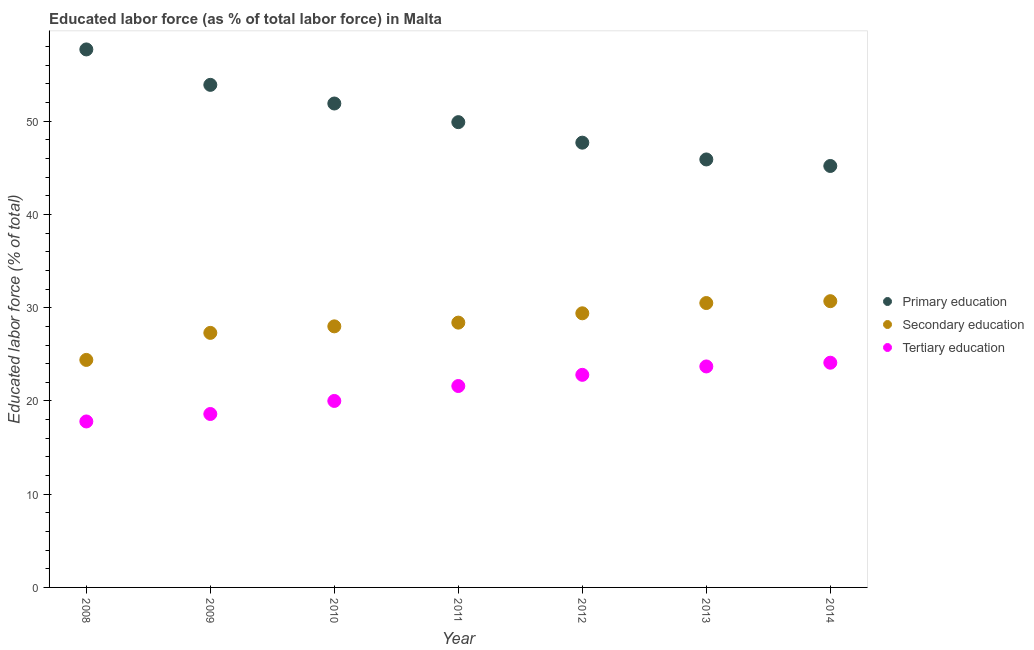Is the number of dotlines equal to the number of legend labels?
Give a very brief answer. Yes. What is the percentage of labor force who received tertiary education in 2013?
Ensure brevity in your answer.  23.7. Across all years, what is the maximum percentage of labor force who received tertiary education?
Provide a short and direct response. 24.1. Across all years, what is the minimum percentage of labor force who received tertiary education?
Keep it short and to the point. 17.8. In which year was the percentage of labor force who received primary education minimum?
Your answer should be very brief. 2014. What is the total percentage of labor force who received secondary education in the graph?
Ensure brevity in your answer.  198.7. What is the difference between the percentage of labor force who received secondary education in 2008 and that in 2013?
Provide a succinct answer. -6.1. What is the difference between the percentage of labor force who received secondary education in 2014 and the percentage of labor force who received primary education in 2013?
Offer a terse response. -15.2. What is the average percentage of labor force who received primary education per year?
Your answer should be compact. 50.31. In the year 2012, what is the difference between the percentage of labor force who received primary education and percentage of labor force who received secondary education?
Your response must be concise. 18.3. What is the ratio of the percentage of labor force who received secondary education in 2010 to that in 2011?
Provide a short and direct response. 0.99. What is the difference between the highest and the second highest percentage of labor force who received secondary education?
Keep it short and to the point. 0.2. What is the difference between the highest and the lowest percentage of labor force who received primary education?
Make the answer very short. 12.5. In how many years, is the percentage of labor force who received secondary education greater than the average percentage of labor force who received secondary education taken over all years?
Offer a very short reply. 4. Is it the case that in every year, the sum of the percentage of labor force who received primary education and percentage of labor force who received secondary education is greater than the percentage of labor force who received tertiary education?
Ensure brevity in your answer.  Yes. Does the percentage of labor force who received primary education monotonically increase over the years?
Offer a very short reply. No. Is the percentage of labor force who received secondary education strictly less than the percentage of labor force who received tertiary education over the years?
Offer a terse response. No. How many dotlines are there?
Offer a terse response. 3. How many years are there in the graph?
Ensure brevity in your answer.  7. What is the difference between two consecutive major ticks on the Y-axis?
Make the answer very short. 10. Does the graph contain any zero values?
Keep it short and to the point. No. How are the legend labels stacked?
Offer a very short reply. Vertical. What is the title of the graph?
Ensure brevity in your answer.  Educated labor force (as % of total labor force) in Malta. Does "Ages 65 and above" appear as one of the legend labels in the graph?
Your answer should be compact. No. What is the label or title of the Y-axis?
Your answer should be compact. Educated labor force (% of total). What is the Educated labor force (% of total) in Primary education in 2008?
Offer a terse response. 57.7. What is the Educated labor force (% of total) of Secondary education in 2008?
Your response must be concise. 24.4. What is the Educated labor force (% of total) in Tertiary education in 2008?
Ensure brevity in your answer.  17.8. What is the Educated labor force (% of total) of Primary education in 2009?
Offer a terse response. 53.9. What is the Educated labor force (% of total) of Secondary education in 2009?
Your response must be concise. 27.3. What is the Educated labor force (% of total) of Tertiary education in 2009?
Your response must be concise. 18.6. What is the Educated labor force (% of total) in Primary education in 2010?
Make the answer very short. 51.9. What is the Educated labor force (% of total) of Tertiary education in 2010?
Offer a terse response. 20. What is the Educated labor force (% of total) in Primary education in 2011?
Offer a very short reply. 49.9. What is the Educated labor force (% of total) of Secondary education in 2011?
Your answer should be compact. 28.4. What is the Educated labor force (% of total) in Tertiary education in 2011?
Keep it short and to the point. 21.6. What is the Educated labor force (% of total) in Primary education in 2012?
Your response must be concise. 47.7. What is the Educated labor force (% of total) of Secondary education in 2012?
Offer a terse response. 29.4. What is the Educated labor force (% of total) of Tertiary education in 2012?
Provide a succinct answer. 22.8. What is the Educated labor force (% of total) in Primary education in 2013?
Make the answer very short. 45.9. What is the Educated labor force (% of total) of Secondary education in 2013?
Provide a short and direct response. 30.5. What is the Educated labor force (% of total) of Tertiary education in 2013?
Your answer should be compact. 23.7. What is the Educated labor force (% of total) of Primary education in 2014?
Your response must be concise. 45.2. What is the Educated labor force (% of total) of Secondary education in 2014?
Provide a succinct answer. 30.7. What is the Educated labor force (% of total) in Tertiary education in 2014?
Your answer should be compact. 24.1. Across all years, what is the maximum Educated labor force (% of total) of Primary education?
Provide a succinct answer. 57.7. Across all years, what is the maximum Educated labor force (% of total) of Secondary education?
Provide a short and direct response. 30.7. Across all years, what is the maximum Educated labor force (% of total) of Tertiary education?
Provide a short and direct response. 24.1. Across all years, what is the minimum Educated labor force (% of total) in Primary education?
Provide a succinct answer. 45.2. Across all years, what is the minimum Educated labor force (% of total) in Secondary education?
Offer a very short reply. 24.4. Across all years, what is the minimum Educated labor force (% of total) in Tertiary education?
Keep it short and to the point. 17.8. What is the total Educated labor force (% of total) of Primary education in the graph?
Ensure brevity in your answer.  352.2. What is the total Educated labor force (% of total) in Secondary education in the graph?
Provide a short and direct response. 198.7. What is the total Educated labor force (% of total) of Tertiary education in the graph?
Offer a very short reply. 148.6. What is the difference between the Educated labor force (% of total) in Primary education in 2008 and that in 2009?
Give a very brief answer. 3.8. What is the difference between the Educated labor force (% of total) in Secondary education in 2008 and that in 2009?
Ensure brevity in your answer.  -2.9. What is the difference between the Educated labor force (% of total) of Secondary education in 2008 and that in 2010?
Offer a very short reply. -3.6. What is the difference between the Educated labor force (% of total) of Tertiary education in 2008 and that in 2010?
Provide a short and direct response. -2.2. What is the difference between the Educated labor force (% of total) in Tertiary education in 2008 and that in 2011?
Your response must be concise. -3.8. What is the difference between the Educated labor force (% of total) of Primary education in 2008 and that in 2012?
Offer a very short reply. 10. What is the difference between the Educated labor force (% of total) in Secondary education in 2008 and that in 2012?
Your answer should be very brief. -5. What is the difference between the Educated labor force (% of total) of Primary education in 2008 and that in 2013?
Give a very brief answer. 11.8. What is the difference between the Educated labor force (% of total) of Tertiary education in 2008 and that in 2013?
Offer a terse response. -5.9. What is the difference between the Educated labor force (% of total) of Secondary education in 2009 and that in 2010?
Your answer should be very brief. -0.7. What is the difference between the Educated labor force (% of total) in Tertiary education in 2009 and that in 2010?
Keep it short and to the point. -1.4. What is the difference between the Educated labor force (% of total) in Secondary education in 2009 and that in 2012?
Make the answer very short. -2.1. What is the difference between the Educated labor force (% of total) of Primary education in 2009 and that in 2013?
Your response must be concise. 8. What is the difference between the Educated labor force (% of total) in Secondary education in 2009 and that in 2013?
Your answer should be very brief. -3.2. What is the difference between the Educated labor force (% of total) in Tertiary education in 2009 and that in 2013?
Your answer should be compact. -5.1. What is the difference between the Educated labor force (% of total) of Secondary education in 2009 and that in 2014?
Make the answer very short. -3.4. What is the difference between the Educated labor force (% of total) in Tertiary education in 2010 and that in 2011?
Your answer should be very brief. -1.6. What is the difference between the Educated labor force (% of total) in Primary education in 2010 and that in 2012?
Your response must be concise. 4.2. What is the difference between the Educated labor force (% of total) in Secondary education in 2010 and that in 2012?
Offer a very short reply. -1.4. What is the difference between the Educated labor force (% of total) of Primary education in 2010 and that in 2013?
Keep it short and to the point. 6. What is the difference between the Educated labor force (% of total) of Tertiary education in 2010 and that in 2013?
Your answer should be very brief. -3.7. What is the difference between the Educated labor force (% of total) of Primary education in 2010 and that in 2014?
Offer a very short reply. 6.7. What is the difference between the Educated labor force (% of total) in Secondary education in 2011 and that in 2012?
Make the answer very short. -1. What is the difference between the Educated labor force (% of total) in Tertiary education in 2011 and that in 2012?
Your response must be concise. -1.2. What is the difference between the Educated labor force (% of total) in Secondary education in 2012 and that in 2013?
Provide a succinct answer. -1.1. What is the difference between the Educated labor force (% of total) of Tertiary education in 2012 and that in 2013?
Make the answer very short. -0.9. What is the difference between the Educated labor force (% of total) of Primary education in 2012 and that in 2014?
Offer a terse response. 2.5. What is the difference between the Educated labor force (% of total) of Secondary education in 2012 and that in 2014?
Make the answer very short. -1.3. What is the difference between the Educated labor force (% of total) in Primary education in 2013 and that in 2014?
Offer a very short reply. 0.7. What is the difference between the Educated labor force (% of total) of Secondary education in 2013 and that in 2014?
Provide a succinct answer. -0.2. What is the difference between the Educated labor force (% of total) in Tertiary education in 2013 and that in 2014?
Offer a very short reply. -0.4. What is the difference between the Educated labor force (% of total) in Primary education in 2008 and the Educated labor force (% of total) in Secondary education in 2009?
Your response must be concise. 30.4. What is the difference between the Educated labor force (% of total) in Primary education in 2008 and the Educated labor force (% of total) in Tertiary education in 2009?
Ensure brevity in your answer.  39.1. What is the difference between the Educated labor force (% of total) in Secondary education in 2008 and the Educated labor force (% of total) in Tertiary education in 2009?
Your response must be concise. 5.8. What is the difference between the Educated labor force (% of total) in Primary education in 2008 and the Educated labor force (% of total) in Secondary education in 2010?
Keep it short and to the point. 29.7. What is the difference between the Educated labor force (% of total) of Primary education in 2008 and the Educated labor force (% of total) of Tertiary education in 2010?
Provide a succinct answer. 37.7. What is the difference between the Educated labor force (% of total) of Secondary education in 2008 and the Educated labor force (% of total) of Tertiary education in 2010?
Keep it short and to the point. 4.4. What is the difference between the Educated labor force (% of total) of Primary education in 2008 and the Educated labor force (% of total) of Secondary education in 2011?
Ensure brevity in your answer.  29.3. What is the difference between the Educated labor force (% of total) of Primary education in 2008 and the Educated labor force (% of total) of Tertiary education in 2011?
Ensure brevity in your answer.  36.1. What is the difference between the Educated labor force (% of total) in Secondary education in 2008 and the Educated labor force (% of total) in Tertiary education in 2011?
Give a very brief answer. 2.8. What is the difference between the Educated labor force (% of total) of Primary education in 2008 and the Educated labor force (% of total) of Secondary education in 2012?
Make the answer very short. 28.3. What is the difference between the Educated labor force (% of total) of Primary education in 2008 and the Educated labor force (% of total) of Tertiary education in 2012?
Keep it short and to the point. 34.9. What is the difference between the Educated labor force (% of total) of Secondary education in 2008 and the Educated labor force (% of total) of Tertiary education in 2012?
Give a very brief answer. 1.6. What is the difference between the Educated labor force (% of total) of Primary education in 2008 and the Educated labor force (% of total) of Secondary education in 2013?
Keep it short and to the point. 27.2. What is the difference between the Educated labor force (% of total) of Primary education in 2008 and the Educated labor force (% of total) of Tertiary education in 2013?
Offer a very short reply. 34. What is the difference between the Educated labor force (% of total) in Secondary education in 2008 and the Educated labor force (% of total) in Tertiary education in 2013?
Ensure brevity in your answer.  0.7. What is the difference between the Educated labor force (% of total) in Primary education in 2008 and the Educated labor force (% of total) in Secondary education in 2014?
Ensure brevity in your answer.  27. What is the difference between the Educated labor force (% of total) of Primary education in 2008 and the Educated labor force (% of total) of Tertiary education in 2014?
Your answer should be very brief. 33.6. What is the difference between the Educated labor force (% of total) of Secondary education in 2008 and the Educated labor force (% of total) of Tertiary education in 2014?
Give a very brief answer. 0.3. What is the difference between the Educated labor force (% of total) in Primary education in 2009 and the Educated labor force (% of total) in Secondary education in 2010?
Give a very brief answer. 25.9. What is the difference between the Educated labor force (% of total) of Primary education in 2009 and the Educated labor force (% of total) of Tertiary education in 2010?
Provide a short and direct response. 33.9. What is the difference between the Educated labor force (% of total) of Secondary education in 2009 and the Educated labor force (% of total) of Tertiary education in 2010?
Make the answer very short. 7.3. What is the difference between the Educated labor force (% of total) in Primary education in 2009 and the Educated labor force (% of total) in Secondary education in 2011?
Make the answer very short. 25.5. What is the difference between the Educated labor force (% of total) of Primary education in 2009 and the Educated labor force (% of total) of Tertiary education in 2011?
Make the answer very short. 32.3. What is the difference between the Educated labor force (% of total) in Primary education in 2009 and the Educated labor force (% of total) in Secondary education in 2012?
Make the answer very short. 24.5. What is the difference between the Educated labor force (% of total) in Primary education in 2009 and the Educated labor force (% of total) in Tertiary education in 2012?
Give a very brief answer. 31.1. What is the difference between the Educated labor force (% of total) of Secondary education in 2009 and the Educated labor force (% of total) of Tertiary education in 2012?
Your answer should be very brief. 4.5. What is the difference between the Educated labor force (% of total) in Primary education in 2009 and the Educated labor force (% of total) in Secondary education in 2013?
Offer a very short reply. 23.4. What is the difference between the Educated labor force (% of total) of Primary education in 2009 and the Educated labor force (% of total) of Tertiary education in 2013?
Offer a very short reply. 30.2. What is the difference between the Educated labor force (% of total) in Secondary education in 2009 and the Educated labor force (% of total) in Tertiary education in 2013?
Keep it short and to the point. 3.6. What is the difference between the Educated labor force (% of total) of Primary education in 2009 and the Educated labor force (% of total) of Secondary education in 2014?
Offer a terse response. 23.2. What is the difference between the Educated labor force (% of total) of Primary education in 2009 and the Educated labor force (% of total) of Tertiary education in 2014?
Ensure brevity in your answer.  29.8. What is the difference between the Educated labor force (% of total) of Secondary education in 2009 and the Educated labor force (% of total) of Tertiary education in 2014?
Your answer should be compact. 3.2. What is the difference between the Educated labor force (% of total) of Primary education in 2010 and the Educated labor force (% of total) of Secondary education in 2011?
Make the answer very short. 23.5. What is the difference between the Educated labor force (% of total) of Primary education in 2010 and the Educated labor force (% of total) of Tertiary education in 2011?
Your response must be concise. 30.3. What is the difference between the Educated labor force (% of total) of Primary education in 2010 and the Educated labor force (% of total) of Secondary education in 2012?
Your answer should be very brief. 22.5. What is the difference between the Educated labor force (% of total) in Primary education in 2010 and the Educated labor force (% of total) in Tertiary education in 2012?
Ensure brevity in your answer.  29.1. What is the difference between the Educated labor force (% of total) in Secondary education in 2010 and the Educated labor force (% of total) in Tertiary education in 2012?
Ensure brevity in your answer.  5.2. What is the difference between the Educated labor force (% of total) of Primary education in 2010 and the Educated labor force (% of total) of Secondary education in 2013?
Provide a succinct answer. 21.4. What is the difference between the Educated labor force (% of total) of Primary education in 2010 and the Educated labor force (% of total) of Tertiary education in 2013?
Your answer should be compact. 28.2. What is the difference between the Educated labor force (% of total) of Secondary education in 2010 and the Educated labor force (% of total) of Tertiary education in 2013?
Offer a very short reply. 4.3. What is the difference between the Educated labor force (% of total) in Primary education in 2010 and the Educated labor force (% of total) in Secondary education in 2014?
Your response must be concise. 21.2. What is the difference between the Educated labor force (% of total) in Primary education in 2010 and the Educated labor force (% of total) in Tertiary education in 2014?
Your response must be concise. 27.8. What is the difference between the Educated labor force (% of total) in Secondary education in 2010 and the Educated labor force (% of total) in Tertiary education in 2014?
Make the answer very short. 3.9. What is the difference between the Educated labor force (% of total) in Primary education in 2011 and the Educated labor force (% of total) in Secondary education in 2012?
Keep it short and to the point. 20.5. What is the difference between the Educated labor force (% of total) of Primary education in 2011 and the Educated labor force (% of total) of Tertiary education in 2012?
Your answer should be compact. 27.1. What is the difference between the Educated labor force (% of total) of Primary education in 2011 and the Educated labor force (% of total) of Secondary education in 2013?
Your answer should be very brief. 19.4. What is the difference between the Educated labor force (% of total) in Primary education in 2011 and the Educated labor force (% of total) in Tertiary education in 2013?
Your answer should be very brief. 26.2. What is the difference between the Educated labor force (% of total) of Secondary education in 2011 and the Educated labor force (% of total) of Tertiary education in 2013?
Ensure brevity in your answer.  4.7. What is the difference between the Educated labor force (% of total) in Primary education in 2011 and the Educated labor force (% of total) in Secondary education in 2014?
Offer a terse response. 19.2. What is the difference between the Educated labor force (% of total) in Primary education in 2011 and the Educated labor force (% of total) in Tertiary education in 2014?
Offer a terse response. 25.8. What is the difference between the Educated labor force (% of total) in Primary education in 2012 and the Educated labor force (% of total) in Tertiary education in 2014?
Offer a terse response. 23.6. What is the difference between the Educated labor force (% of total) of Primary education in 2013 and the Educated labor force (% of total) of Tertiary education in 2014?
Offer a very short reply. 21.8. What is the average Educated labor force (% of total) in Primary education per year?
Your answer should be very brief. 50.31. What is the average Educated labor force (% of total) of Secondary education per year?
Your answer should be compact. 28.39. What is the average Educated labor force (% of total) of Tertiary education per year?
Give a very brief answer. 21.23. In the year 2008, what is the difference between the Educated labor force (% of total) in Primary education and Educated labor force (% of total) in Secondary education?
Provide a succinct answer. 33.3. In the year 2008, what is the difference between the Educated labor force (% of total) of Primary education and Educated labor force (% of total) of Tertiary education?
Provide a succinct answer. 39.9. In the year 2009, what is the difference between the Educated labor force (% of total) of Primary education and Educated labor force (% of total) of Secondary education?
Keep it short and to the point. 26.6. In the year 2009, what is the difference between the Educated labor force (% of total) of Primary education and Educated labor force (% of total) of Tertiary education?
Give a very brief answer. 35.3. In the year 2009, what is the difference between the Educated labor force (% of total) in Secondary education and Educated labor force (% of total) in Tertiary education?
Provide a succinct answer. 8.7. In the year 2010, what is the difference between the Educated labor force (% of total) in Primary education and Educated labor force (% of total) in Secondary education?
Your answer should be very brief. 23.9. In the year 2010, what is the difference between the Educated labor force (% of total) in Primary education and Educated labor force (% of total) in Tertiary education?
Your answer should be very brief. 31.9. In the year 2011, what is the difference between the Educated labor force (% of total) in Primary education and Educated labor force (% of total) in Secondary education?
Make the answer very short. 21.5. In the year 2011, what is the difference between the Educated labor force (% of total) of Primary education and Educated labor force (% of total) of Tertiary education?
Offer a very short reply. 28.3. In the year 2012, what is the difference between the Educated labor force (% of total) in Primary education and Educated labor force (% of total) in Secondary education?
Your response must be concise. 18.3. In the year 2012, what is the difference between the Educated labor force (% of total) in Primary education and Educated labor force (% of total) in Tertiary education?
Offer a very short reply. 24.9. In the year 2013, what is the difference between the Educated labor force (% of total) in Primary education and Educated labor force (% of total) in Secondary education?
Provide a succinct answer. 15.4. In the year 2013, what is the difference between the Educated labor force (% of total) of Primary education and Educated labor force (% of total) of Tertiary education?
Your answer should be very brief. 22.2. In the year 2013, what is the difference between the Educated labor force (% of total) of Secondary education and Educated labor force (% of total) of Tertiary education?
Provide a short and direct response. 6.8. In the year 2014, what is the difference between the Educated labor force (% of total) in Primary education and Educated labor force (% of total) in Tertiary education?
Your answer should be very brief. 21.1. What is the ratio of the Educated labor force (% of total) in Primary education in 2008 to that in 2009?
Your response must be concise. 1.07. What is the ratio of the Educated labor force (% of total) in Secondary education in 2008 to that in 2009?
Offer a terse response. 0.89. What is the ratio of the Educated labor force (% of total) in Primary education in 2008 to that in 2010?
Provide a short and direct response. 1.11. What is the ratio of the Educated labor force (% of total) in Secondary education in 2008 to that in 2010?
Make the answer very short. 0.87. What is the ratio of the Educated labor force (% of total) of Tertiary education in 2008 to that in 2010?
Offer a very short reply. 0.89. What is the ratio of the Educated labor force (% of total) of Primary education in 2008 to that in 2011?
Give a very brief answer. 1.16. What is the ratio of the Educated labor force (% of total) in Secondary education in 2008 to that in 2011?
Your response must be concise. 0.86. What is the ratio of the Educated labor force (% of total) in Tertiary education in 2008 to that in 2011?
Make the answer very short. 0.82. What is the ratio of the Educated labor force (% of total) of Primary education in 2008 to that in 2012?
Your response must be concise. 1.21. What is the ratio of the Educated labor force (% of total) in Secondary education in 2008 to that in 2012?
Ensure brevity in your answer.  0.83. What is the ratio of the Educated labor force (% of total) of Tertiary education in 2008 to that in 2012?
Keep it short and to the point. 0.78. What is the ratio of the Educated labor force (% of total) in Primary education in 2008 to that in 2013?
Give a very brief answer. 1.26. What is the ratio of the Educated labor force (% of total) in Secondary education in 2008 to that in 2013?
Provide a succinct answer. 0.8. What is the ratio of the Educated labor force (% of total) of Tertiary education in 2008 to that in 2013?
Keep it short and to the point. 0.75. What is the ratio of the Educated labor force (% of total) of Primary education in 2008 to that in 2014?
Offer a very short reply. 1.28. What is the ratio of the Educated labor force (% of total) in Secondary education in 2008 to that in 2014?
Your answer should be very brief. 0.79. What is the ratio of the Educated labor force (% of total) in Tertiary education in 2008 to that in 2014?
Offer a very short reply. 0.74. What is the ratio of the Educated labor force (% of total) of Secondary education in 2009 to that in 2010?
Keep it short and to the point. 0.97. What is the ratio of the Educated labor force (% of total) of Primary education in 2009 to that in 2011?
Keep it short and to the point. 1.08. What is the ratio of the Educated labor force (% of total) of Secondary education in 2009 to that in 2011?
Provide a short and direct response. 0.96. What is the ratio of the Educated labor force (% of total) of Tertiary education in 2009 to that in 2011?
Provide a succinct answer. 0.86. What is the ratio of the Educated labor force (% of total) of Primary education in 2009 to that in 2012?
Keep it short and to the point. 1.13. What is the ratio of the Educated labor force (% of total) of Tertiary education in 2009 to that in 2012?
Offer a terse response. 0.82. What is the ratio of the Educated labor force (% of total) in Primary education in 2009 to that in 2013?
Offer a terse response. 1.17. What is the ratio of the Educated labor force (% of total) of Secondary education in 2009 to that in 2013?
Your answer should be very brief. 0.9. What is the ratio of the Educated labor force (% of total) of Tertiary education in 2009 to that in 2013?
Ensure brevity in your answer.  0.78. What is the ratio of the Educated labor force (% of total) in Primary education in 2009 to that in 2014?
Provide a short and direct response. 1.19. What is the ratio of the Educated labor force (% of total) in Secondary education in 2009 to that in 2014?
Make the answer very short. 0.89. What is the ratio of the Educated labor force (% of total) of Tertiary education in 2009 to that in 2014?
Give a very brief answer. 0.77. What is the ratio of the Educated labor force (% of total) in Primary education in 2010 to that in 2011?
Make the answer very short. 1.04. What is the ratio of the Educated labor force (% of total) of Secondary education in 2010 to that in 2011?
Give a very brief answer. 0.99. What is the ratio of the Educated labor force (% of total) of Tertiary education in 2010 to that in 2011?
Offer a terse response. 0.93. What is the ratio of the Educated labor force (% of total) of Primary education in 2010 to that in 2012?
Ensure brevity in your answer.  1.09. What is the ratio of the Educated labor force (% of total) of Secondary education in 2010 to that in 2012?
Offer a terse response. 0.95. What is the ratio of the Educated labor force (% of total) in Tertiary education in 2010 to that in 2012?
Provide a succinct answer. 0.88. What is the ratio of the Educated labor force (% of total) in Primary education in 2010 to that in 2013?
Provide a short and direct response. 1.13. What is the ratio of the Educated labor force (% of total) of Secondary education in 2010 to that in 2013?
Ensure brevity in your answer.  0.92. What is the ratio of the Educated labor force (% of total) of Tertiary education in 2010 to that in 2013?
Ensure brevity in your answer.  0.84. What is the ratio of the Educated labor force (% of total) in Primary education in 2010 to that in 2014?
Make the answer very short. 1.15. What is the ratio of the Educated labor force (% of total) in Secondary education in 2010 to that in 2014?
Offer a terse response. 0.91. What is the ratio of the Educated labor force (% of total) in Tertiary education in 2010 to that in 2014?
Your answer should be compact. 0.83. What is the ratio of the Educated labor force (% of total) in Primary education in 2011 to that in 2012?
Your response must be concise. 1.05. What is the ratio of the Educated labor force (% of total) of Tertiary education in 2011 to that in 2012?
Provide a short and direct response. 0.95. What is the ratio of the Educated labor force (% of total) in Primary education in 2011 to that in 2013?
Offer a very short reply. 1.09. What is the ratio of the Educated labor force (% of total) in Secondary education in 2011 to that in 2013?
Ensure brevity in your answer.  0.93. What is the ratio of the Educated labor force (% of total) in Tertiary education in 2011 to that in 2013?
Ensure brevity in your answer.  0.91. What is the ratio of the Educated labor force (% of total) in Primary education in 2011 to that in 2014?
Keep it short and to the point. 1.1. What is the ratio of the Educated labor force (% of total) in Secondary education in 2011 to that in 2014?
Keep it short and to the point. 0.93. What is the ratio of the Educated labor force (% of total) of Tertiary education in 2011 to that in 2014?
Ensure brevity in your answer.  0.9. What is the ratio of the Educated labor force (% of total) in Primary education in 2012 to that in 2013?
Give a very brief answer. 1.04. What is the ratio of the Educated labor force (% of total) in Secondary education in 2012 to that in 2013?
Your answer should be very brief. 0.96. What is the ratio of the Educated labor force (% of total) of Tertiary education in 2012 to that in 2013?
Provide a short and direct response. 0.96. What is the ratio of the Educated labor force (% of total) of Primary education in 2012 to that in 2014?
Your answer should be very brief. 1.06. What is the ratio of the Educated labor force (% of total) of Secondary education in 2012 to that in 2014?
Give a very brief answer. 0.96. What is the ratio of the Educated labor force (% of total) of Tertiary education in 2012 to that in 2014?
Give a very brief answer. 0.95. What is the ratio of the Educated labor force (% of total) in Primary education in 2013 to that in 2014?
Your answer should be very brief. 1.02. What is the ratio of the Educated labor force (% of total) in Tertiary education in 2013 to that in 2014?
Make the answer very short. 0.98. What is the difference between the highest and the second highest Educated labor force (% of total) of Secondary education?
Give a very brief answer. 0.2. 